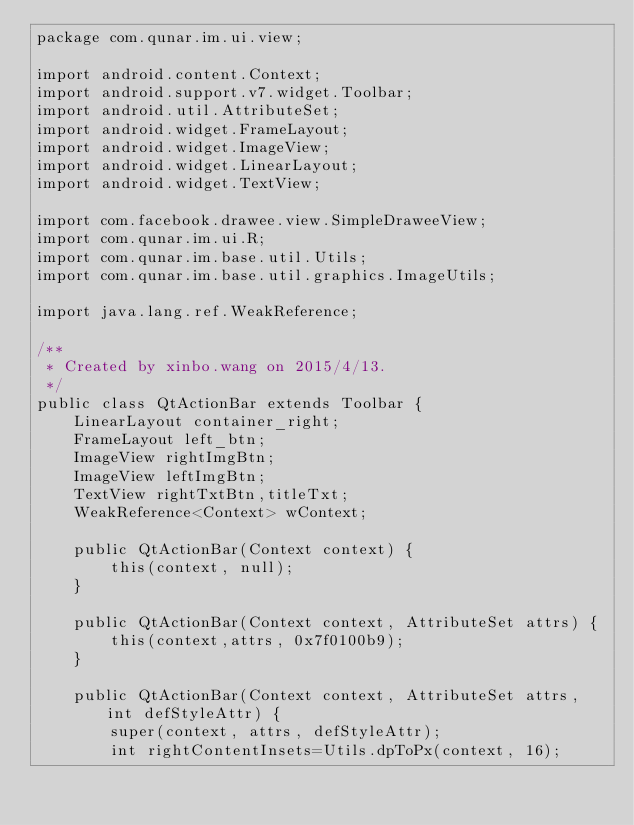<code> <loc_0><loc_0><loc_500><loc_500><_Java_>package com.qunar.im.ui.view;

import android.content.Context;
import android.support.v7.widget.Toolbar;
import android.util.AttributeSet;
import android.widget.FrameLayout;
import android.widget.ImageView;
import android.widget.LinearLayout;
import android.widget.TextView;

import com.facebook.drawee.view.SimpleDraweeView;
import com.qunar.im.ui.R;
import com.qunar.im.base.util.Utils;
import com.qunar.im.base.util.graphics.ImageUtils;

import java.lang.ref.WeakReference;

/**
 * Created by xinbo.wang on 2015/4/13.
 */
public class QtActionBar extends Toolbar {
    LinearLayout container_right;
    FrameLayout left_btn;
    ImageView rightImgBtn;
    ImageView leftImgBtn;
    TextView rightTxtBtn,titleTxt;
    WeakReference<Context> wContext;

    public QtActionBar(Context context) {
        this(context, null);
    }

    public QtActionBar(Context context, AttributeSet attrs) {
        this(context,attrs, 0x7f0100b9);
    }

    public QtActionBar(Context context, AttributeSet attrs, int defStyleAttr) {
        super(context, attrs, defStyleAttr);
        int rightContentInsets=Utils.dpToPx(context, 16);</code> 